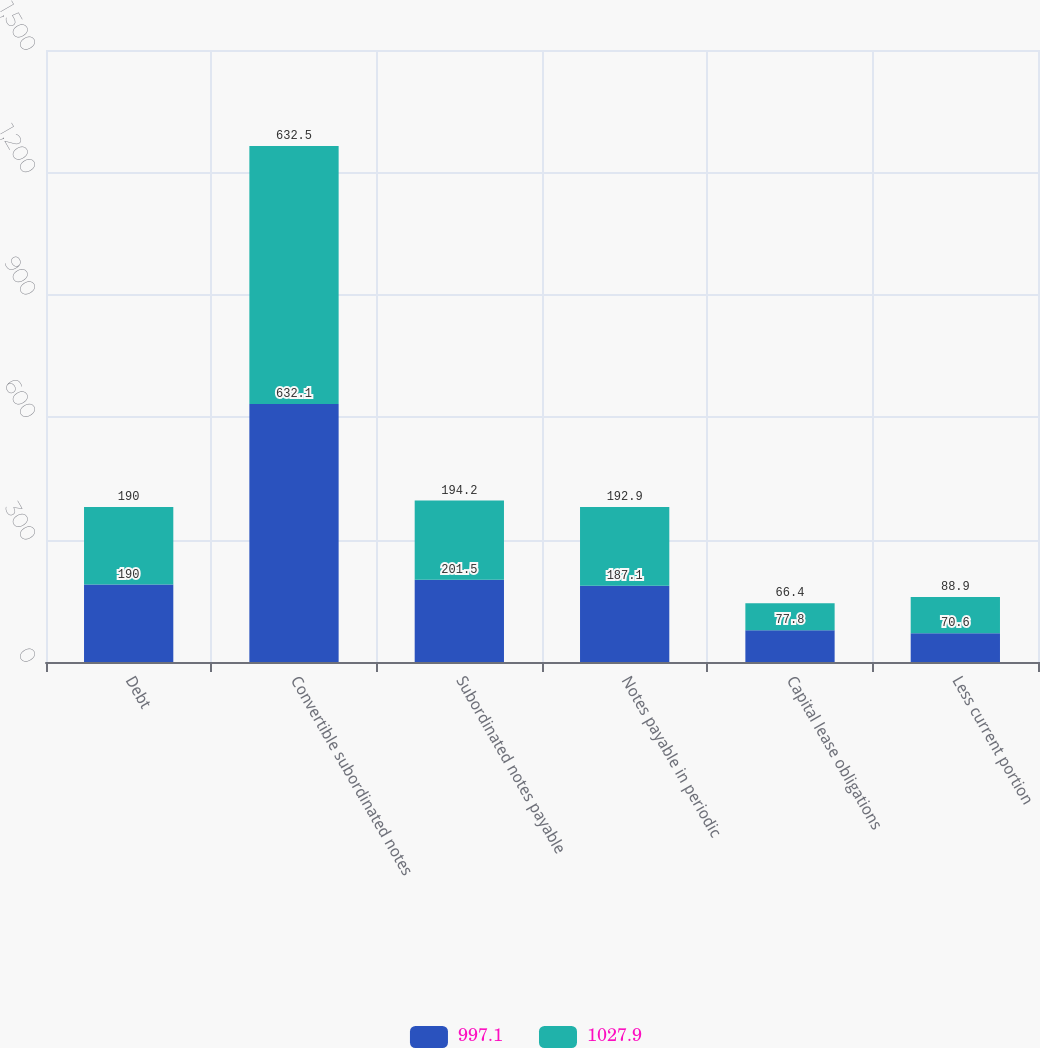<chart> <loc_0><loc_0><loc_500><loc_500><stacked_bar_chart><ecel><fcel>Debt<fcel>Convertible subordinated notes<fcel>Subordinated notes payable<fcel>Notes payable in periodic<fcel>Capital lease obligations<fcel>Less current portion<nl><fcel>997.1<fcel>190<fcel>632.1<fcel>201.5<fcel>187.1<fcel>77.8<fcel>70.6<nl><fcel>1027.9<fcel>190<fcel>632.5<fcel>194.2<fcel>192.9<fcel>66.4<fcel>88.9<nl></chart> 